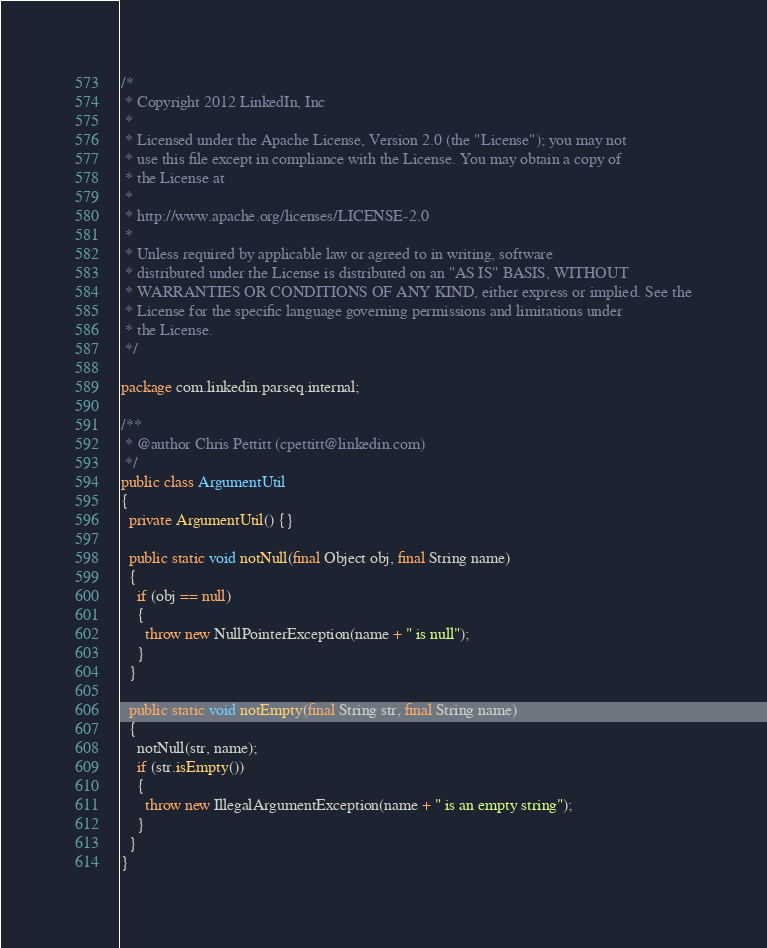<code> <loc_0><loc_0><loc_500><loc_500><_Java_>/*
 * Copyright 2012 LinkedIn, Inc
 *
 * Licensed under the Apache License, Version 2.0 (the "License"); you may not
 * use this file except in compliance with the License. You may obtain a copy of
 * the License at
 *
 * http://www.apache.org/licenses/LICENSE-2.0
 *
 * Unless required by applicable law or agreed to in writing, software
 * distributed under the License is distributed on an "AS IS" BASIS, WITHOUT
 * WARRANTIES OR CONDITIONS OF ANY KIND, either express or implied. See the
 * License for the specific language governing permissions and limitations under
 * the License.
 */

package com.linkedin.parseq.internal;

/**
 * @author Chris Pettitt (cpettitt@linkedin.com)
 */
public class ArgumentUtil
{
  private ArgumentUtil() {}

  public static void notNull(final Object obj, final String name)
  {
    if (obj == null)
    {
      throw new NullPointerException(name + " is null");
    }
  }

  public static void notEmpty(final String str, final String name)
  {
    notNull(str, name);
    if (str.isEmpty())
    {
      throw new IllegalArgumentException(name + " is an empty string");
    }
  }
}
</code> 